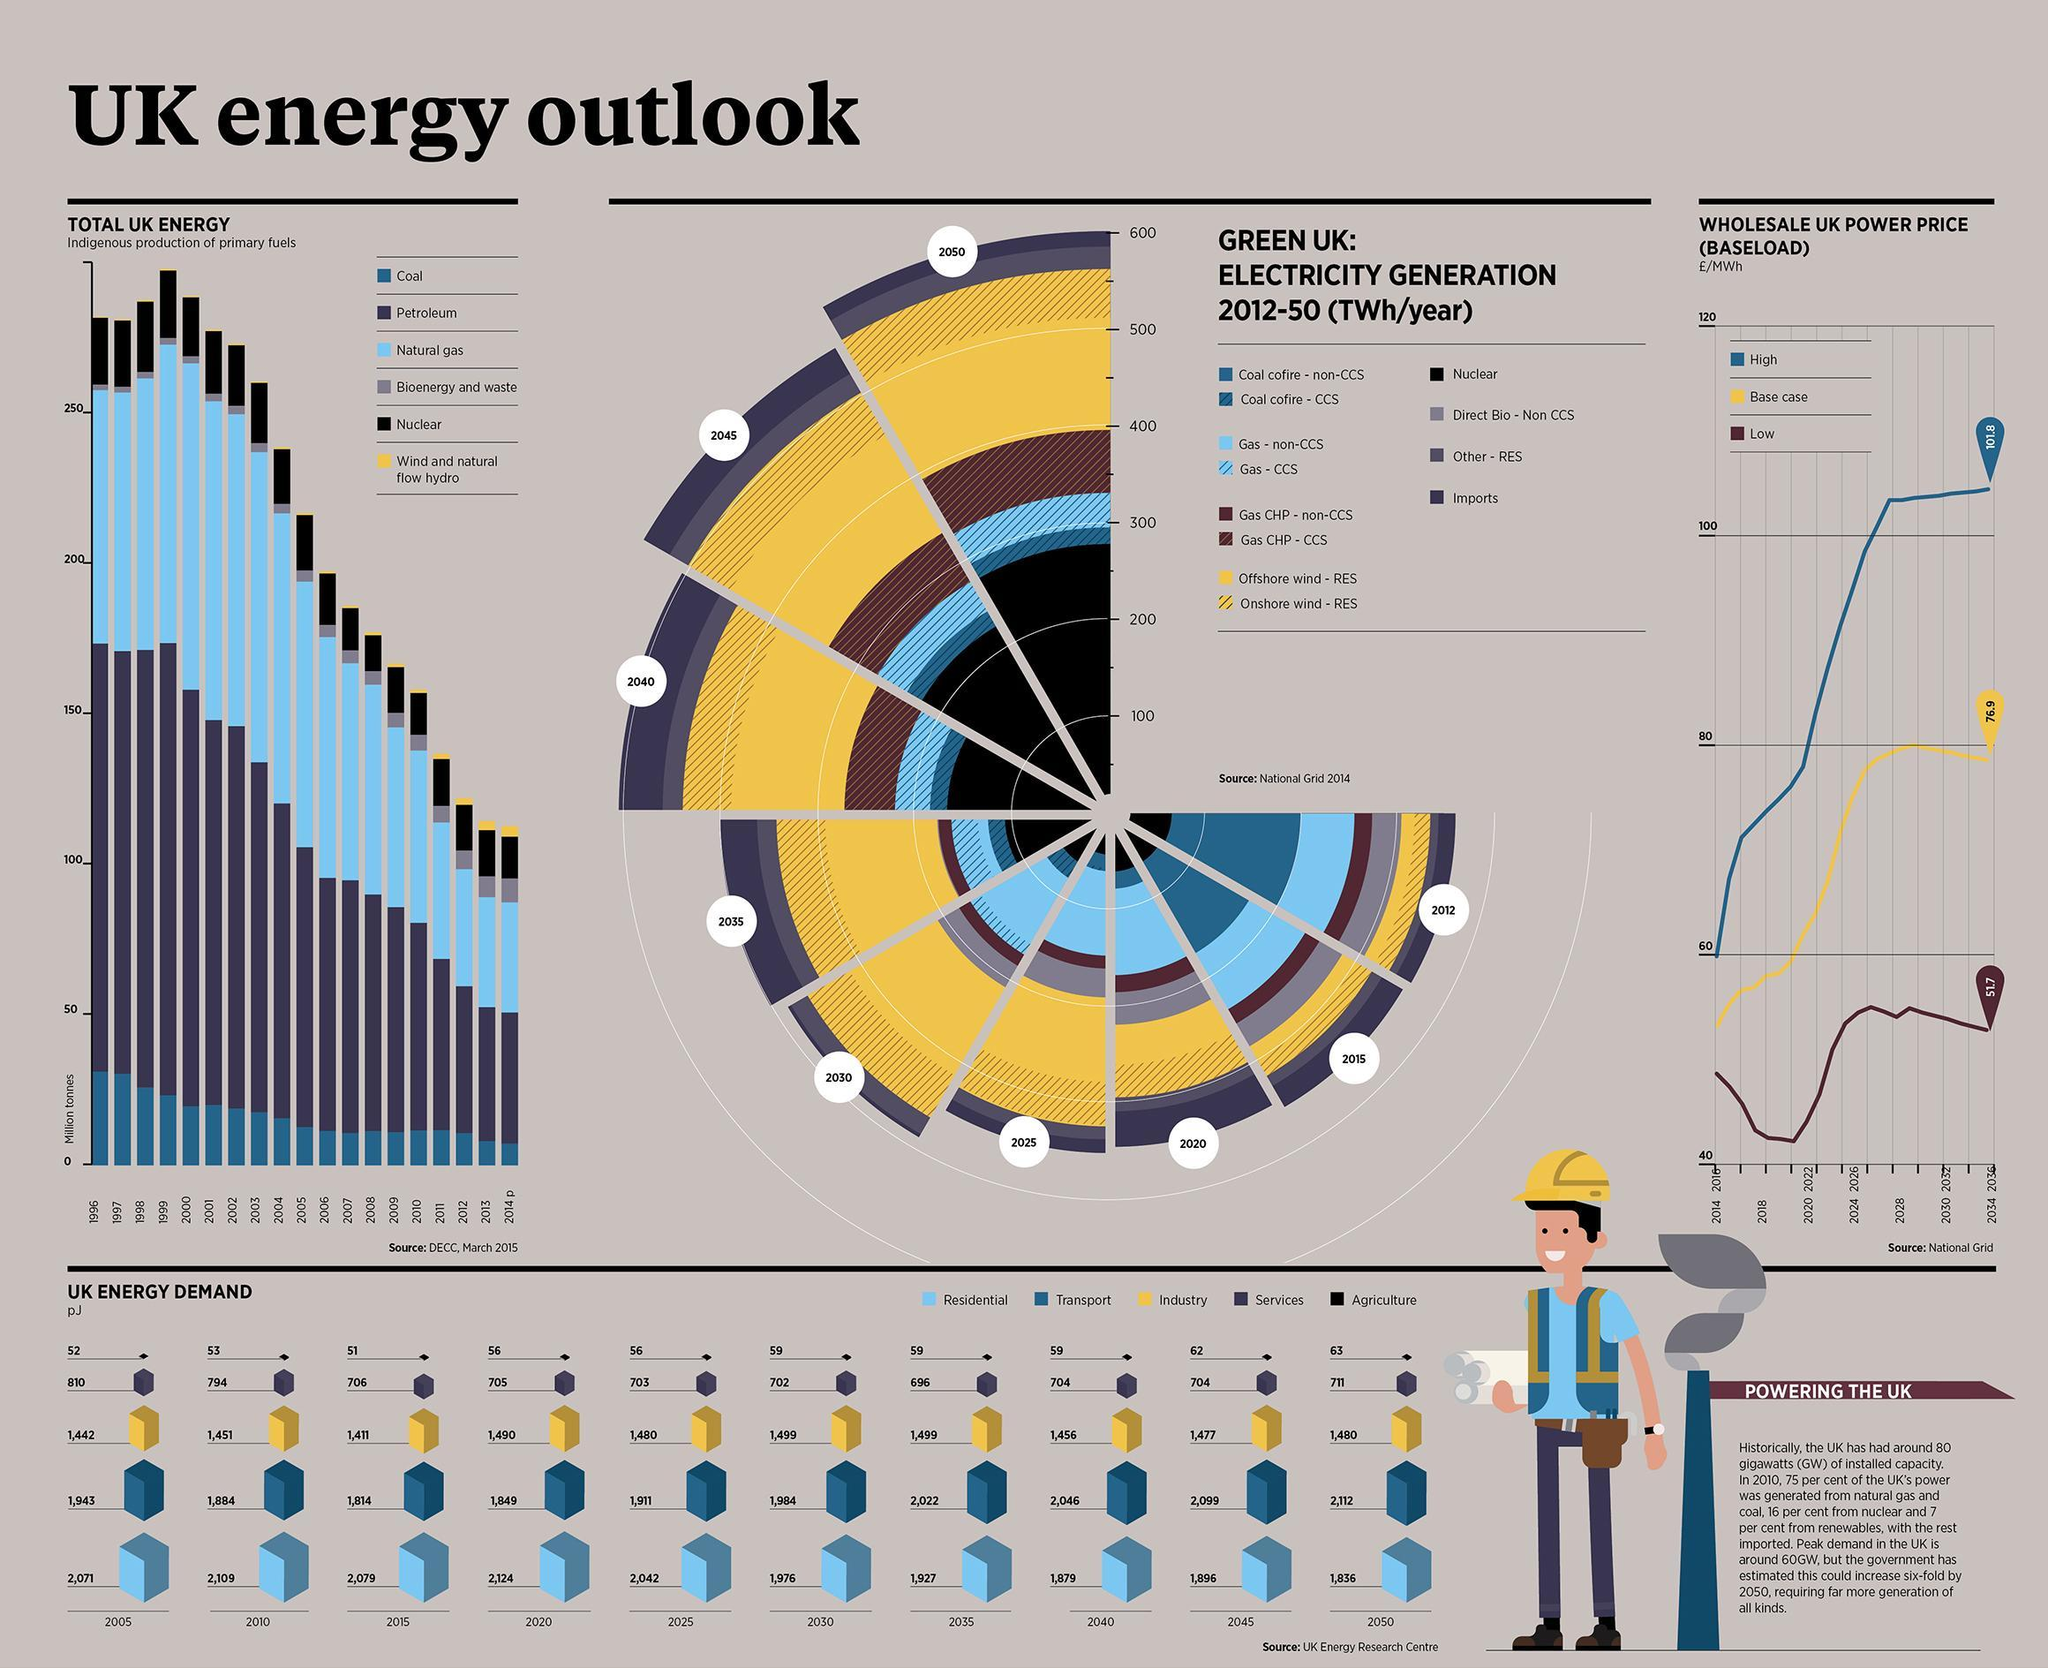What is the projected estimate of UK's energy demand (in pJ) in transport sector by 2045?
Answer the question with a short phrase. 2,099 What is the projected estimate of UK's energy demand (in pJ) in transport sector by 2040? 2,046 What is the UK's energy demand (in pJ) in service sector in 2005? 810 In which sector, UK had highest rate of energy consumption in 2010? Residential What is the UK's energy demand (in pJ) in agricultural sector in 2015? 51 What is the projected estimate of UK's energy demand (in pJ) in industrial sector by 2050? 1,480 